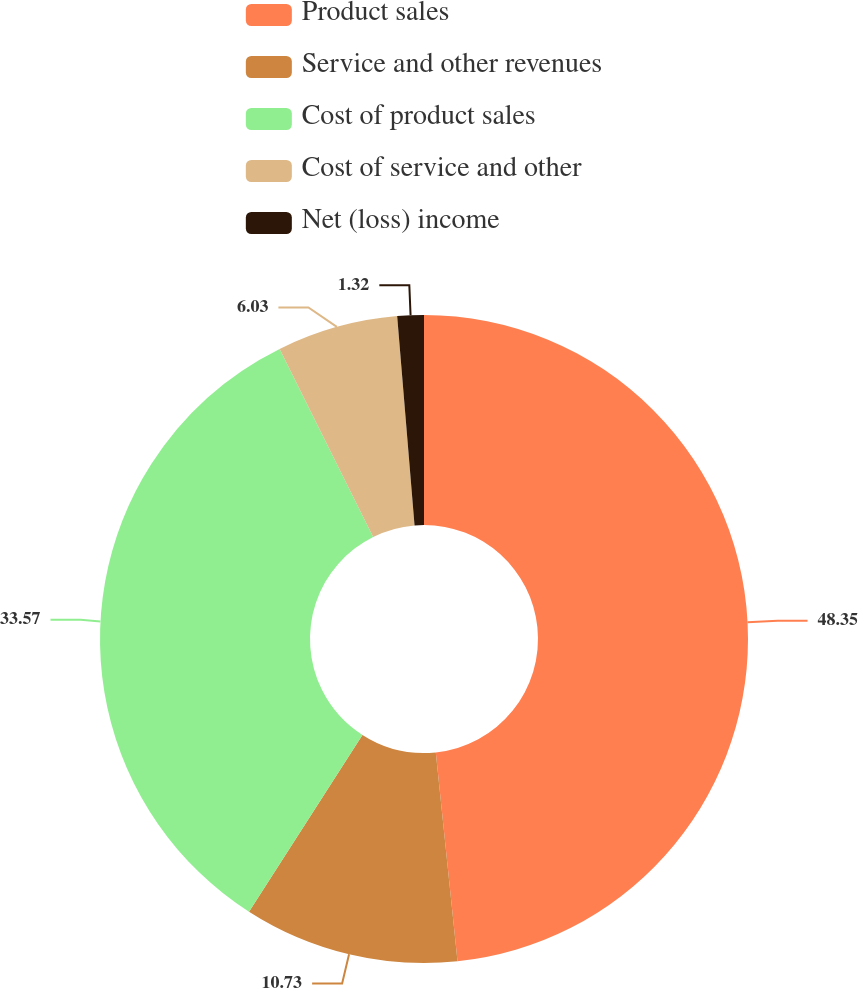<chart> <loc_0><loc_0><loc_500><loc_500><pie_chart><fcel>Product sales<fcel>Service and other revenues<fcel>Cost of product sales<fcel>Cost of service and other<fcel>Net (loss) income<nl><fcel>48.35%<fcel>10.73%<fcel>33.57%<fcel>6.03%<fcel>1.32%<nl></chart> 